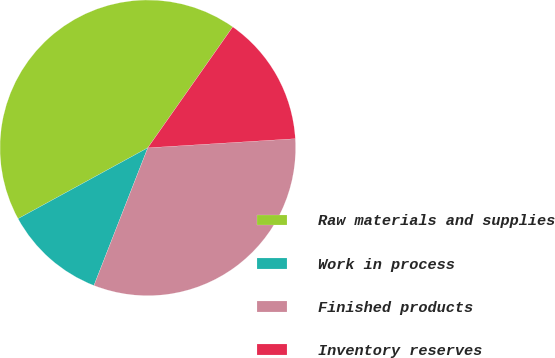Convert chart. <chart><loc_0><loc_0><loc_500><loc_500><pie_chart><fcel>Raw materials and supplies<fcel>Work in process<fcel>Finished products<fcel>Inventory reserves<nl><fcel>42.71%<fcel>11.11%<fcel>31.92%<fcel>14.27%<nl></chart> 